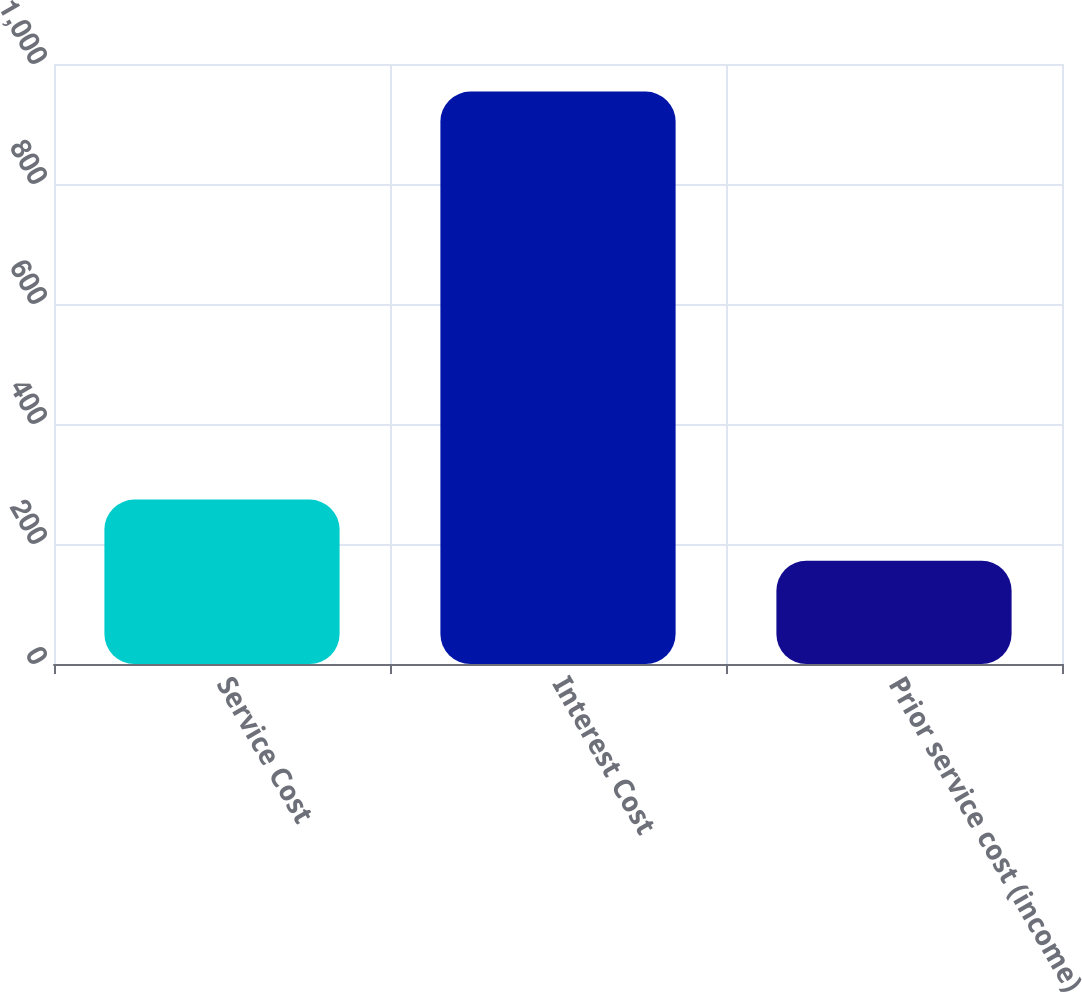<chart> <loc_0><loc_0><loc_500><loc_500><bar_chart><fcel>Service Cost<fcel>Interest Cost<fcel>Prior service cost (income)<nl><fcel>274<fcel>954<fcel>172<nl></chart> 